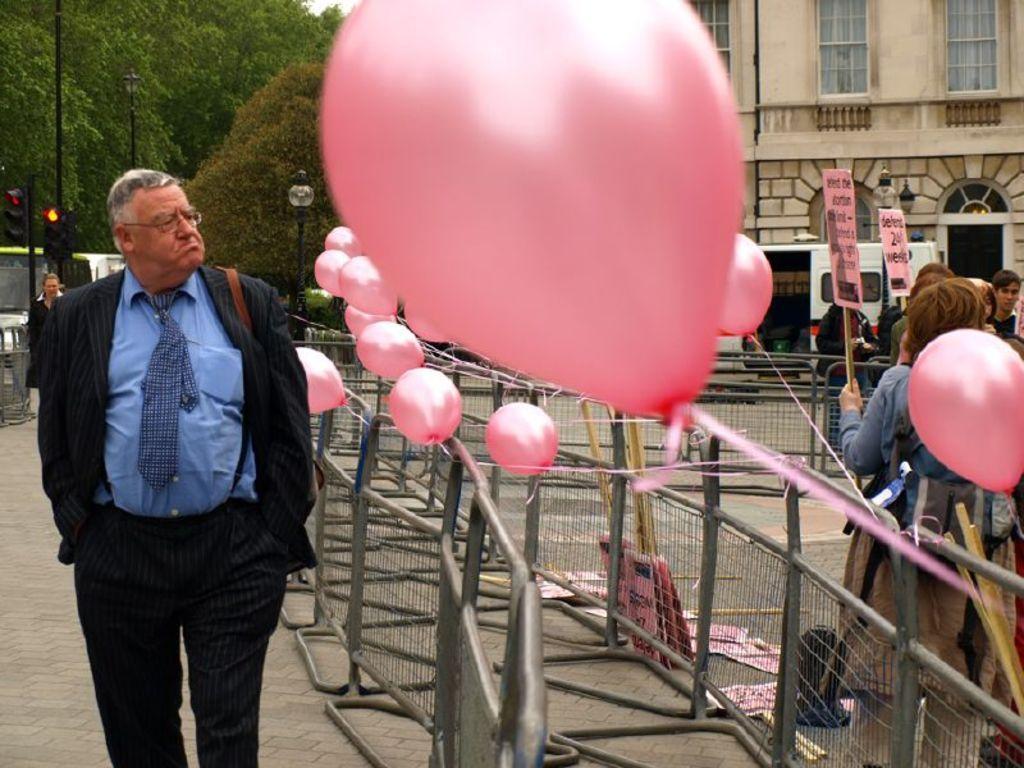Describe this image in one or two sentences. In this picture there are people and we can see fence, boards with sticks and balloons. In the background of the image we can see vehicles, building, trees, poles, lights and traffic signals. 